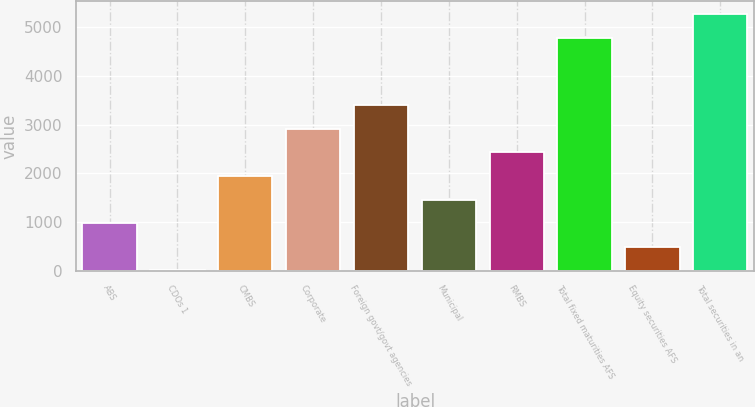Convert chart to OTSL. <chart><loc_0><loc_0><loc_500><loc_500><bar_chart><fcel>ABS<fcel>CDOs 1<fcel>CMBS<fcel>Corporate<fcel>Foreign govt/govt agencies<fcel>Municipal<fcel>RMBS<fcel>Total fixed maturities AFS<fcel>Equity securities AFS<fcel>Total securities in an<nl><fcel>974.2<fcel>4<fcel>1944.4<fcel>2914.6<fcel>3399.7<fcel>1459.3<fcel>2429.5<fcel>4788<fcel>489.1<fcel>5273.1<nl></chart> 